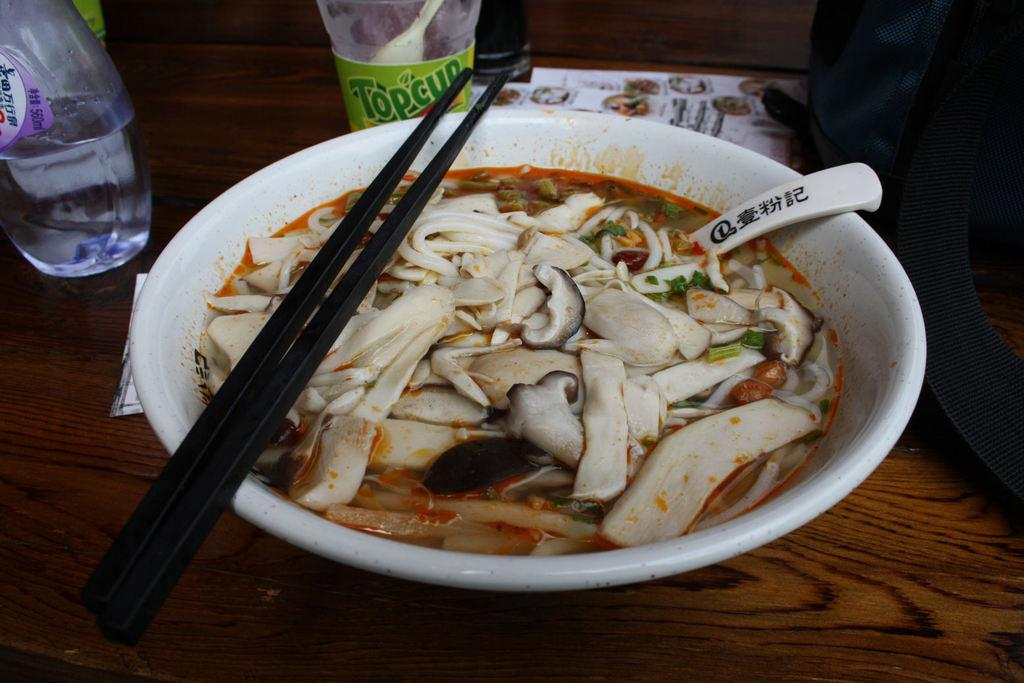<image>
Describe the image concisely. A noodle dish sits in front of a Topcup juice bottle. 